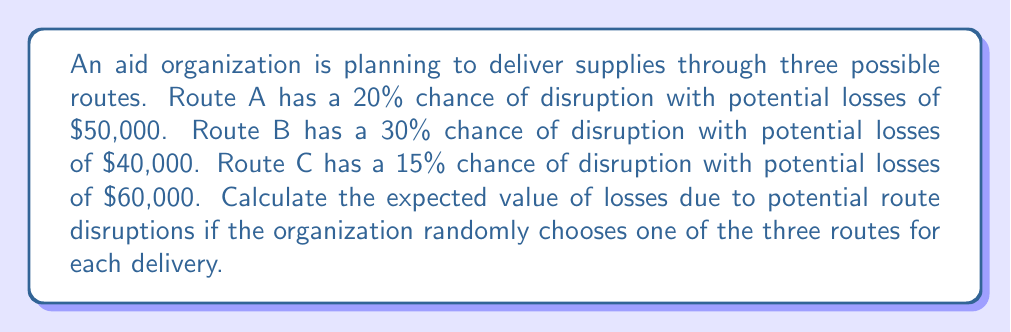What is the answer to this math problem? To calculate the expected value of losses, we need to:
1. Calculate the expected loss for each route
2. Sum up the probabilities of choosing each route multiplied by their respective expected losses

Step 1: Calculate expected loss for each route
- Route A: $E(A) = 0.20 \times \$50,000 = \$10,000$
- Route B: $E(B) = 0.30 \times \$40,000 = \$12,000$
- Route C: $E(C) = 0.15 \times \$60,000 = \$9,000$

Step 2: Calculate the probability of choosing each route
Since the organization randomly chooses one of the three routes, the probability of choosing each route is $\frac{1}{3}$.

Step 3: Calculate the expected value of losses
$$E(\text{losses}) = \frac{1}{3}E(A) + \frac{1}{3}E(B) + \frac{1}{3}E(C)$$
$$E(\text{losses}) = \frac{1}{3}(\$10,000) + \frac{1}{3}(\$12,000) + \frac{1}{3}(\$9,000)$$
$$E(\text{losses}) = \$3,333.33 + \$4,000 + \$3,000$$
$$E(\text{losses}) = \$10,333.33$$
Answer: $\$10,333.33$ 